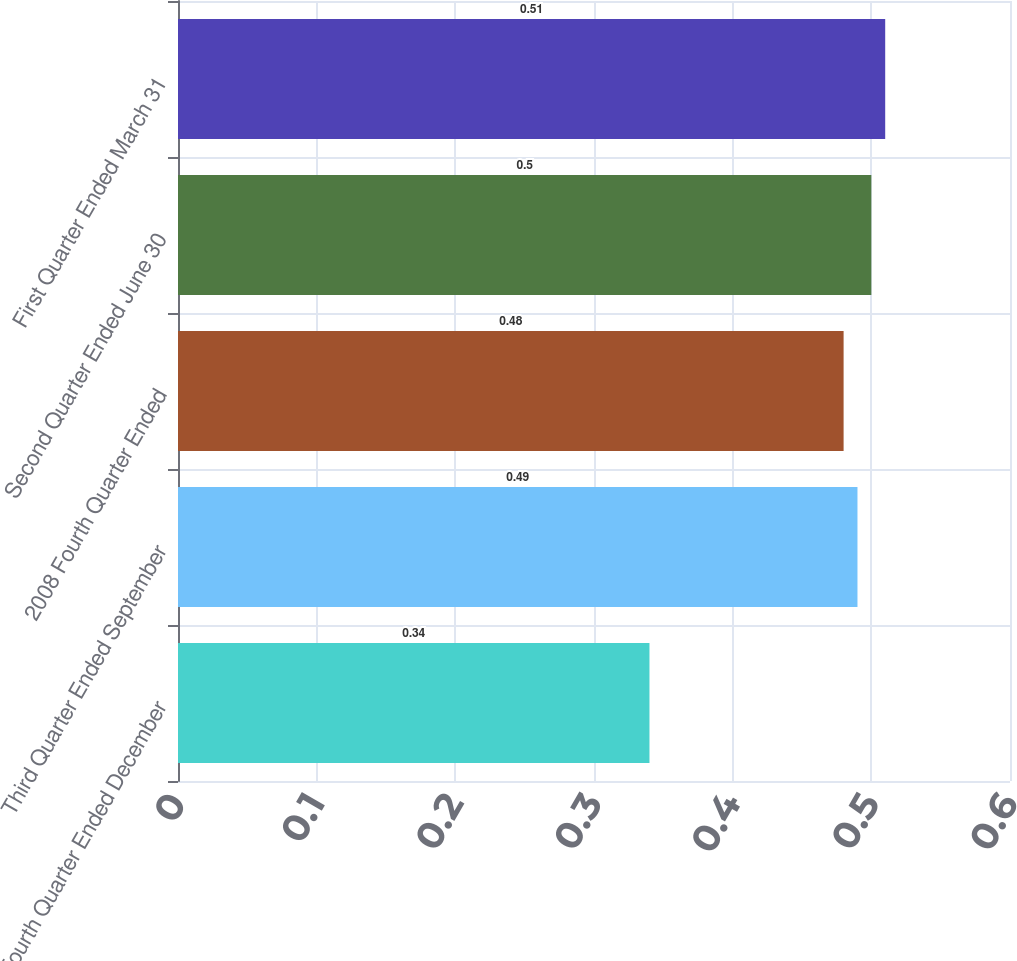<chart> <loc_0><loc_0><loc_500><loc_500><bar_chart><fcel>Fourth Quarter Ended December<fcel>Third Quarter Ended September<fcel>2008 Fourth Quarter Ended<fcel>Second Quarter Ended June 30<fcel>First Quarter Ended March 31<nl><fcel>0.34<fcel>0.49<fcel>0.48<fcel>0.5<fcel>0.51<nl></chart> 